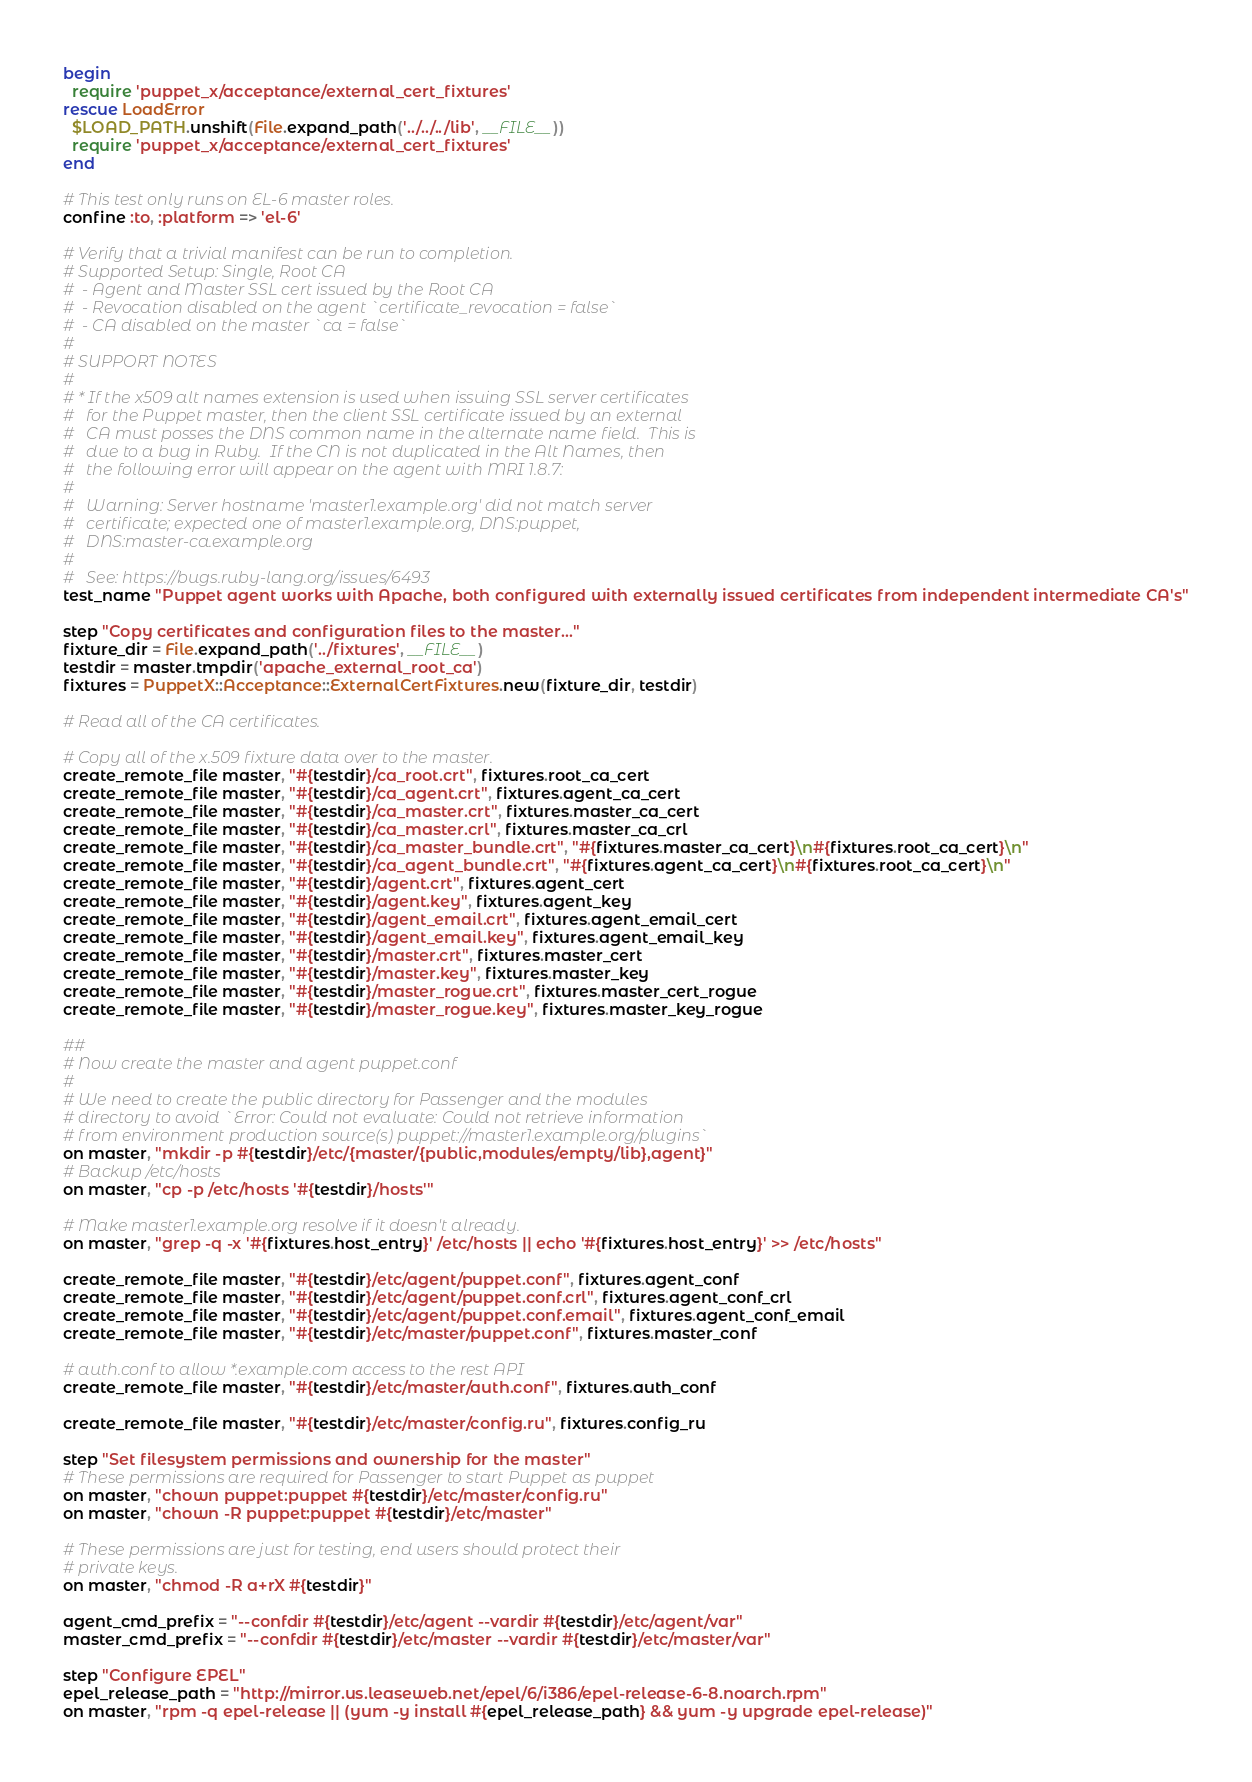Convert code to text. <code><loc_0><loc_0><loc_500><loc_500><_Ruby_>begin
  require 'puppet_x/acceptance/external_cert_fixtures'
rescue LoadError
  $LOAD_PATH.unshift(File.expand_path('../../../lib', __FILE__))
  require 'puppet_x/acceptance/external_cert_fixtures'
end

# This test only runs on EL-6 master roles.
confine :to, :platform => 'el-6'

# Verify that a trivial manifest can be run to completion.
# Supported Setup: Single, Root CA
#  - Agent and Master SSL cert issued by the Root CA
#  - Revocation disabled on the agent `certificate_revocation = false`
#  - CA disabled on the master `ca = false`
#
# SUPPORT NOTES
#
# * If the x509 alt names extension is used when issuing SSL server certificates
#   for the Puppet master, then the client SSL certificate issued by an external
#   CA must posses the DNS common name in the alternate name field.  This is
#   due to a bug in Ruby.  If the CN is not duplicated in the Alt Names, then
#   the following error will appear on the agent with MRI 1.8.7:
#
#   Warning: Server hostname 'master1.example.org' did not match server
#   certificate; expected one of master1.example.org, DNS:puppet,
#   DNS:master-ca.example.org
#
#   See: https://bugs.ruby-lang.org/issues/6493
test_name "Puppet agent works with Apache, both configured with externally issued certificates from independent intermediate CA's"

step "Copy certificates and configuration files to the master..."
fixture_dir = File.expand_path('../fixtures', __FILE__)
testdir = master.tmpdir('apache_external_root_ca')
fixtures = PuppetX::Acceptance::ExternalCertFixtures.new(fixture_dir, testdir)

# Read all of the CA certificates.

# Copy all of the x.509 fixture data over to the master.
create_remote_file master, "#{testdir}/ca_root.crt", fixtures.root_ca_cert
create_remote_file master, "#{testdir}/ca_agent.crt", fixtures.agent_ca_cert
create_remote_file master, "#{testdir}/ca_master.crt", fixtures.master_ca_cert
create_remote_file master, "#{testdir}/ca_master.crl", fixtures.master_ca_crl
create_remote_file master, "#{testdir}/ca_master_bundle.crt", "#{fixtures.master_ca_cert}\n#{fixtures.root_ca_cert}\n"
create_remote_file master, "#{testdir}/ca_agent_bundle.crt", "#{fixtures.agent_ca_cert}\n#{fixtures.root_ca_cert}\n"
create_remote_file master, "#{testdir}/agent.crt", fixtures.agent_cert
create_remote_file master, "#{testdir}/agent.key", fixtures.agent_key
create_remote_file master, "#{testdir}/agent_email.crt", fixtures.agent_email_cert
create_remote_file master, "#{testdir}/agent_email.key", fixtures.agent_email_key
create_remote_file master, "#{testdir}/master.crt", fixtures.master_cert
create_remote_file master, "#{testdir}/master.key", fixtures.master_key
create_remote_file master, "#{testdir}/master_rogue.crt", fixtures.master_cert_rogue
create_remote_file master, "#{testdir}/master_rogue.key", fixtures.master_key_rogue

##
# Now create the master and agent puppet.conf
#
# We need to create the public directory for Passenger and the modules
# directory to avoid `Error: Could not evaluate: Could not retrieve information
# from environment production source(s) puppet://master1.example.org/plugins`
on master, "mkdir -p #{testdir}/etc/{master/{public,modules/empty/lib},agent}"
# Backup /etc/hosts
on master, "cp -p /etc/hosts '#{testdir}/hosts'"

# Make master1.example.org resolve if it doesn't already.
on master, "grep -q -x '#{fixtures.host_entry}' /etc/hosts || echo '#{fixtures.host_entry}' >> /etc/hosts"

create_remote_file master, "#{testdir}/etc/agent/puppet.conf", fixtures.agent_conf
create_remote_file master, "#{testdir}/etc/agent/puppet.conf.crl", fixtures.agent_conf_crl
create_remote_file master, "#{testdir}/etc/agent/puppet.conf.email", fixtures.agent_conf_email
create_remote_file master, "#{testdir}/etc/master/puppet.conf", fixtures.master_conf

# auth.conf to allow *.example.com access to the rest API
create_remote_file master, "#{testdir}/etc/master/auth.conf", fixtures.auth_conf

create_remote_file master, "#{testdir}/etc/master/config.ru", fixtures.config_ru

step "Set filesystem permissions and ownership for the master"
# These permissions are required for Passenger to start Puppet as puppet
on master, "chown puppet:puppet #{testdir}/etc/master/config.ru"
on master, "chown -R puppet:puppet #{testdir}/etc/master"

# These permissions are just for testing, end users should protect their
# private keys.
on master, "chmod -R a+rX #{testdir}"

agent_cmd_prefix = "--confdir #{testdir}/etc/agent --vardir #{testdir}/etc/agent/var"
master_cmd_prefix = "--confdir #{testdir}/etc/master --vardir #{testdir}/etc/master/var"

step "Configure EPEL"
epel_release_path = "http://mirror.us.leaseweb.net/epel/6/i386/epel-release-6-8.noarch.rpm"
on master, "rpm -q epel-release || (yum -y install #{epel_release_path} && yum -y upgrade epel-release)"
</code> 